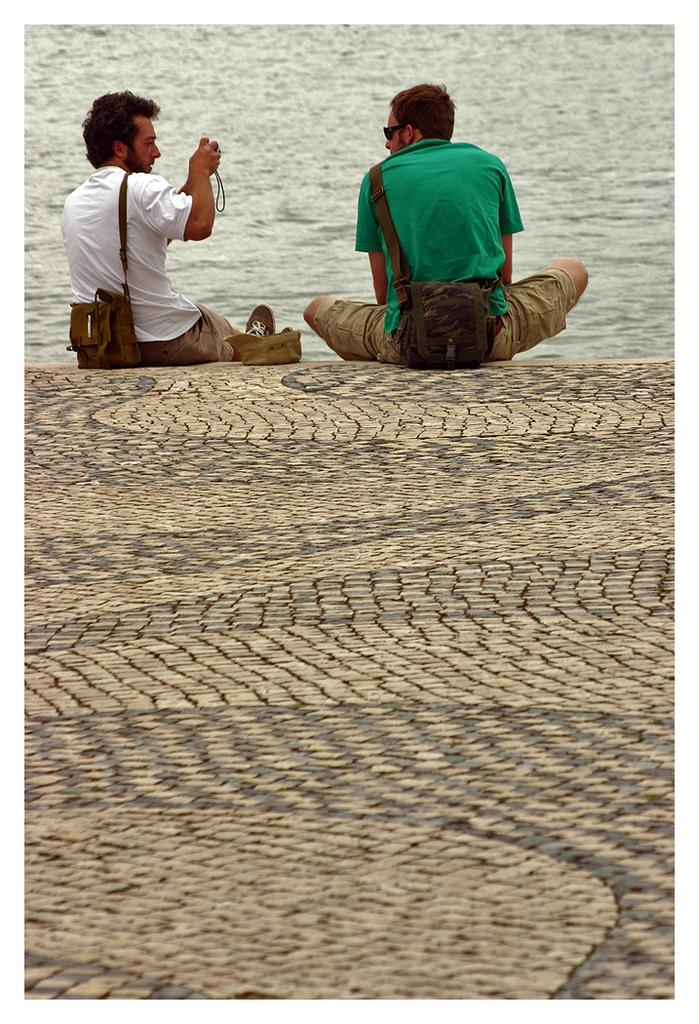How many people are in the image? There are two men in the image. What are the men doing in the image? The men are sitting on the ground. What can be seen in the background of the image? There is water visible in the background of the image. Can you see a tiger playing on a swing in the image? No, there is no tiger or swing present in the image. 